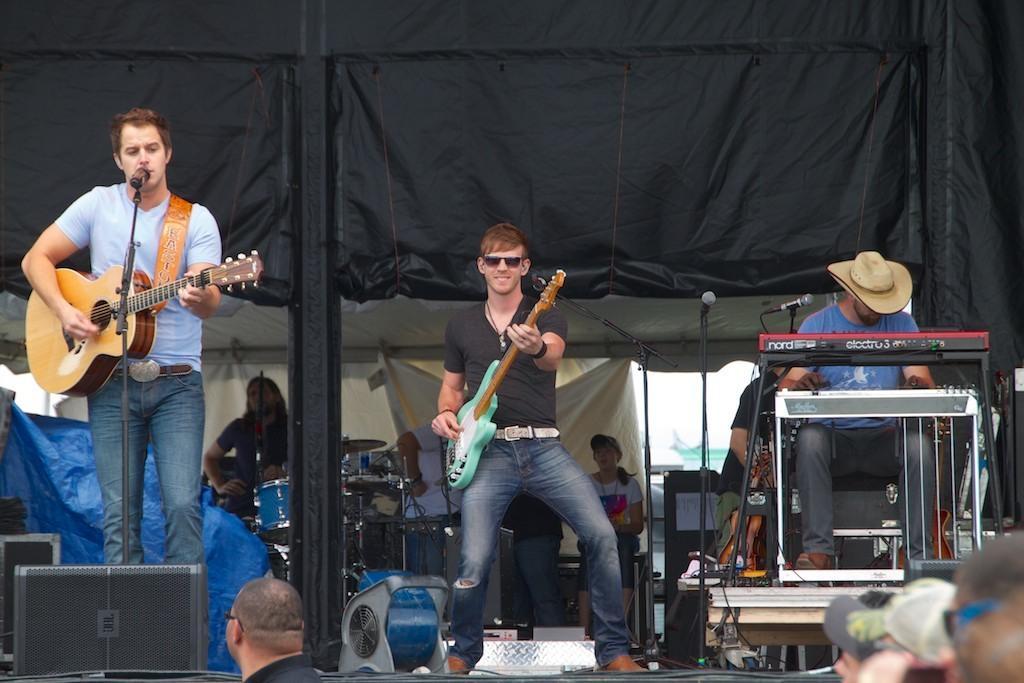Please provide a concise description of this image. Here a man is playing the guitar also singing in the microphone in the middle a man is dancing. 